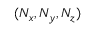<formula> <loc_0><loc_0><loc_500><loc_500>( N _ { x } , N _ { y } , N _ { z } )</formula> 